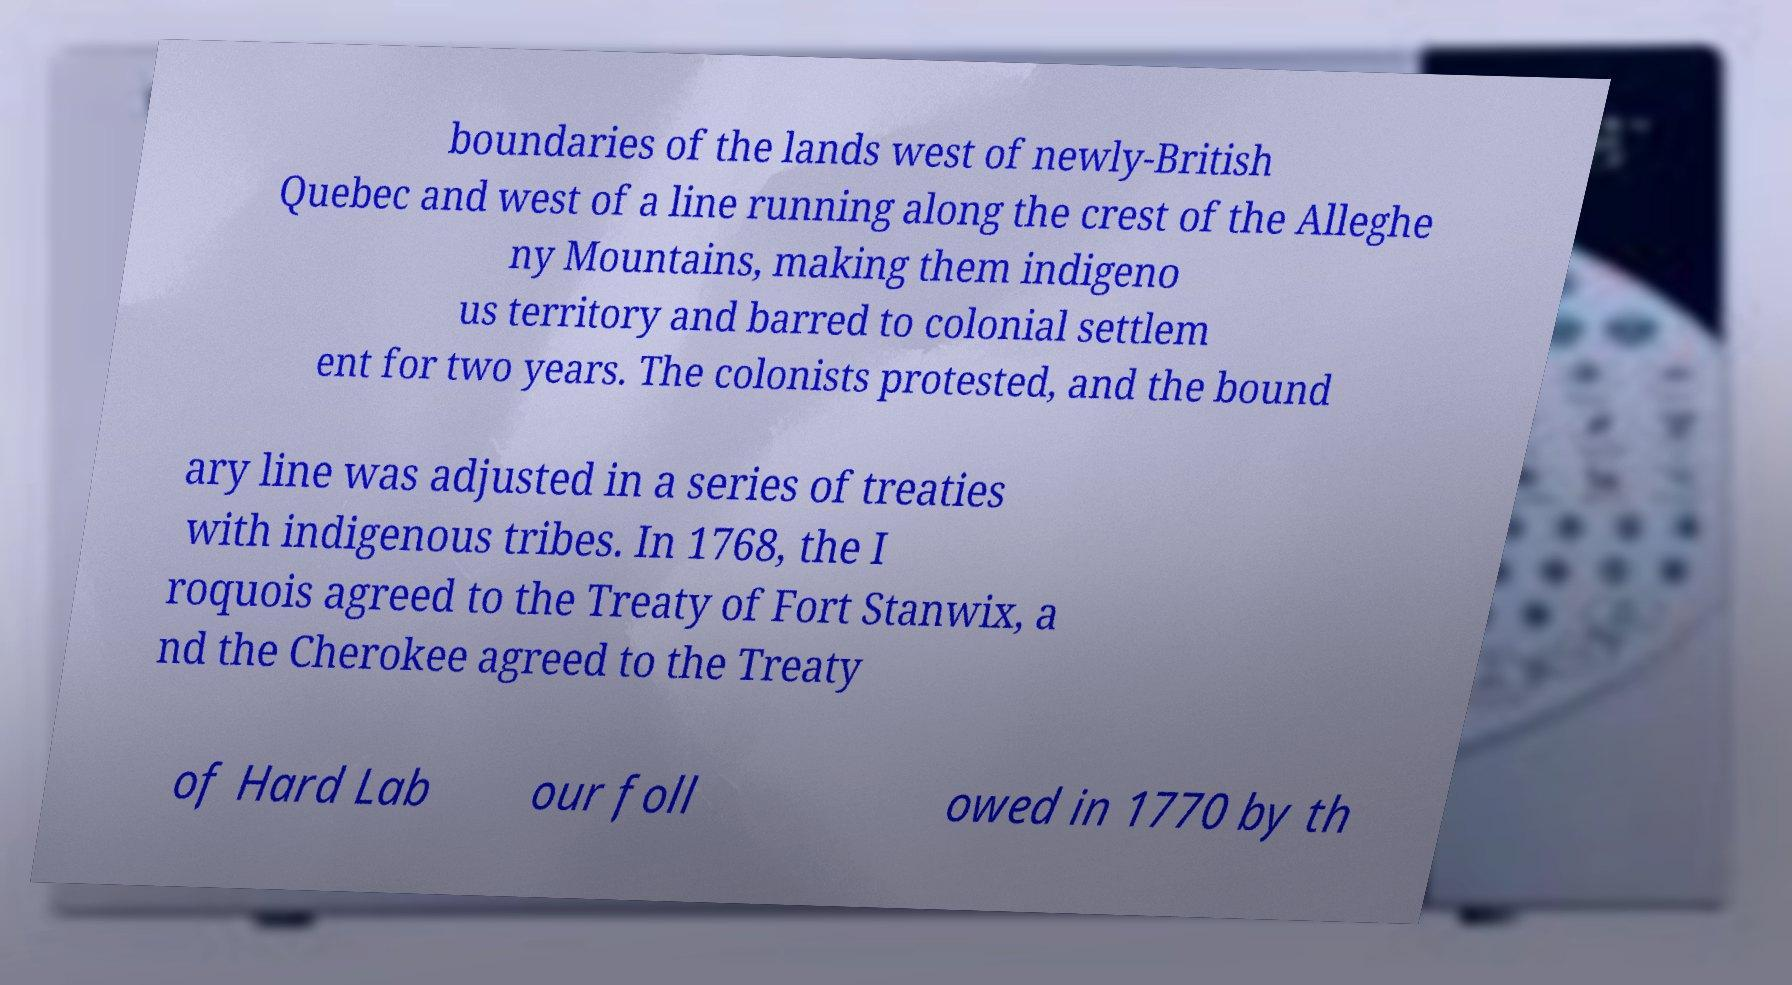Could you extract and type out the text from this image? boundaries of the lands west of newly-British Quebec and west of a line running along the crest of the Alleghe ny Mountains, making them indigeno us territory and barred to colonial settlem ent for two years. The colonists protested, and the bound ary line was adjusted in a series of treaties with indigenous tribes. In 1768, the I roquois agreed to the Treaty of Fort Stanwix, a nd the Cherokee agreed to the Treaty of Hard Lab our foll owed in 1770 by th 